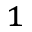Convert formula to latex. <formula><loc_0><loc_0><loc_500><loc_500>^ { 1 }</formula> 